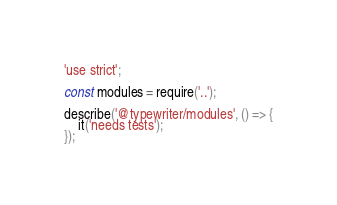<code> <loc_0><loc_0><loc_500><loc_500><_JavaScript_>'use strict';

const modules = require('..');

describe('@typewriter/modules', () => {
    it('needs tests');
});
</code> 